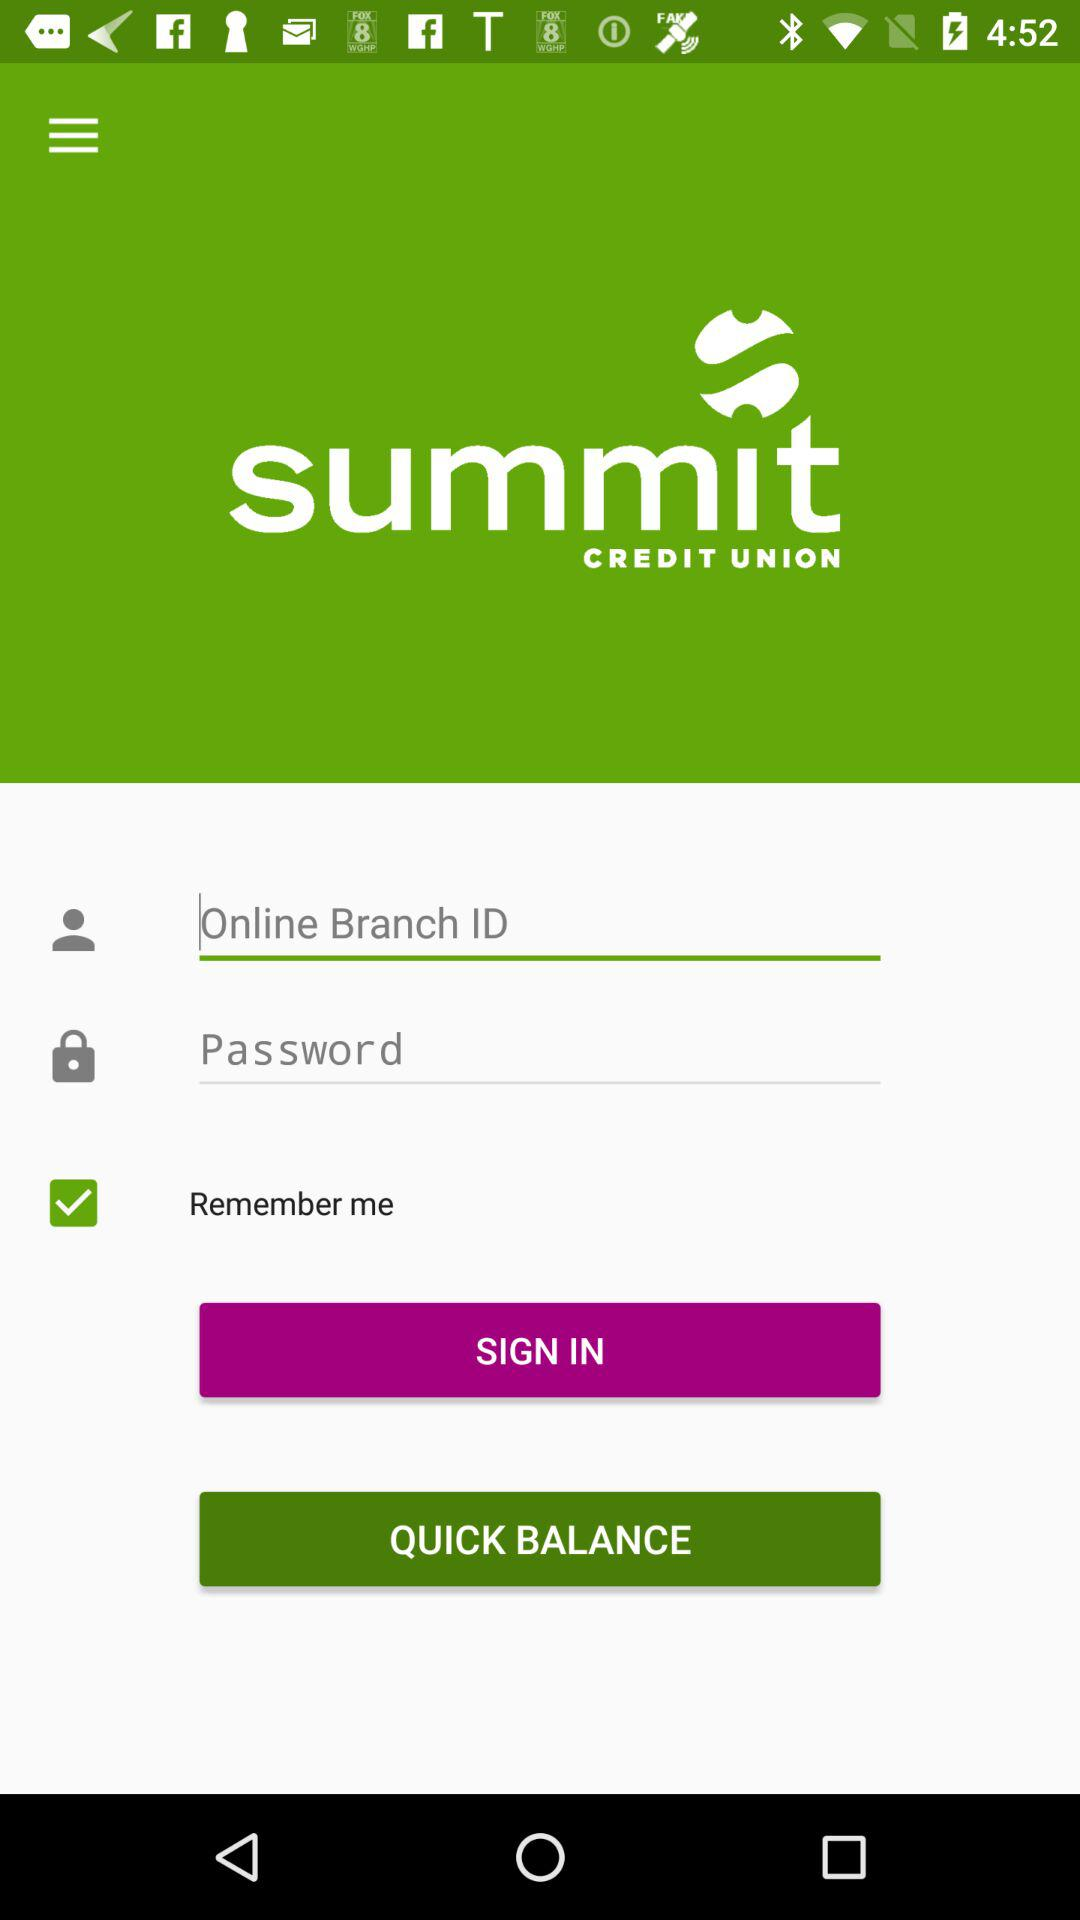What is the name of the application? The name of the application is "summit CREDIT UNION". 